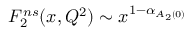Convert formula to latex. <formula><loc_0><loc_0><loc_500><loc_500>F _ { 2 } ^ { n s } ( x , Q ^ { 2 } ) \sim x ^ { 1 - \alpha _ { A _ { 2 } ( 0 ) } }</formula> 